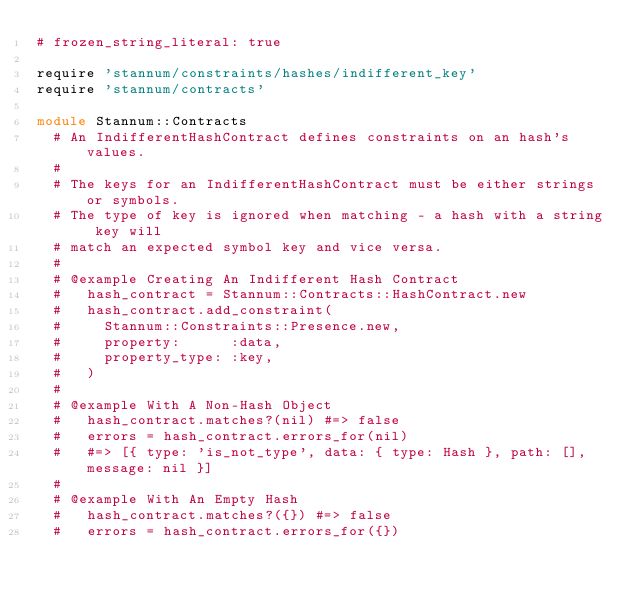Convert code to text. <code><loc_0><loc_0><loc_500><loc_500><_Ruby_># frozen_string_literal: true

require 'stannum/constraints/hashes/indifferent_key'
require 'stannum/contracts'

module Stannum::Contracts
  # An IndifferentHashContract defines constraints on an hash's values.
  #
  # The keys for an IndifferentHashContract must be either strings or symbols.
  # The type of key is ignored when matching - a hash with a string key will
  # match an expected symbol key and vice versa.
  #
  # @example Creating An Indifferent Hash Contract
  #   hash_contract = Stannum::Contracts::HashContract.new
  #   hash_contract.add_constraint(
  #     Stannum::Constraints::Presence.new,
  #     property:      :data,
  #     property_type: :key,
  #   )
  #
  # @example With A Non-Hash Object
  #   hash_contract.matches?(nil) #=> false
  #   errors = hash_contract.errors_for(nil)
  #   #=> [{ type: 'is_not_type', data: { type: Hash }, path: [], message: nil }]
  #
  # @example With An Empty Hash
  #   hash_contract.matches?({}) #=> false
  #   errors = hash_contract.errors_for({})</code> 